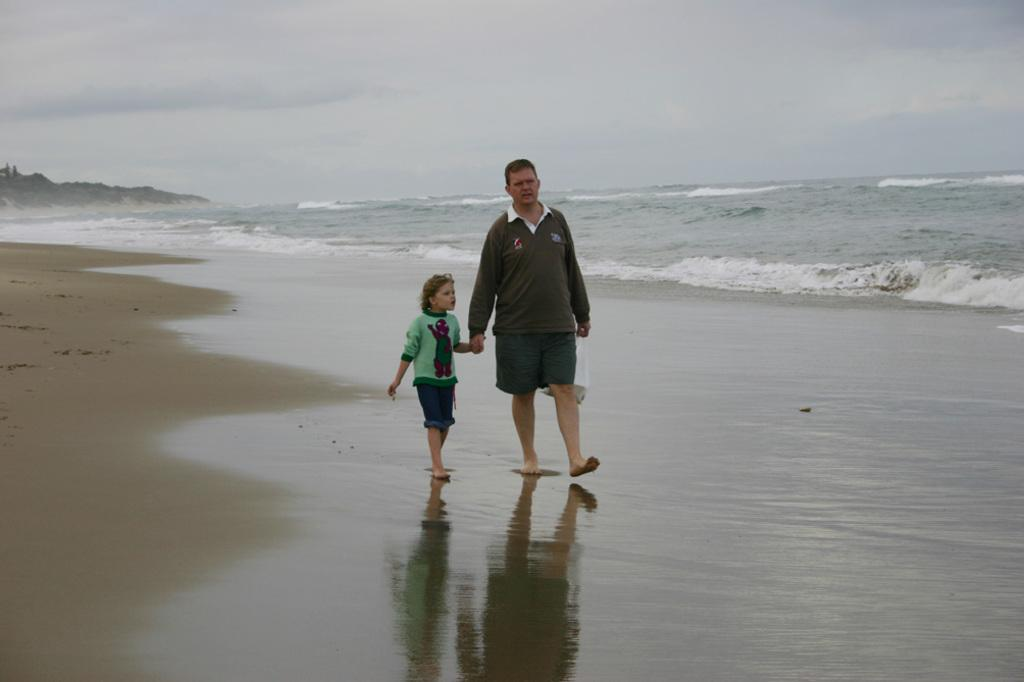Who is present in the image? There is a man and a kid in the image. What are the man and the kid doing in the image? Both the man and the kid are walking on the side of the beach. What can be seen in the background of the image? There is a hill and the sky visible in the background of the image. What is the condition of the sky in the image? Clouds are present in the sky. What decision did the trees make in the image? There are no trees present in the image, so no decision can be attributed to them. 